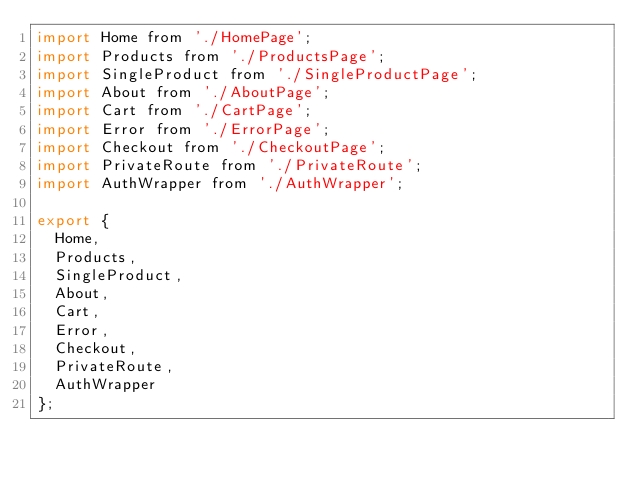Convert code to text. <code><loc_0><loc_0><loc_500><loc_500><_JavaScript_>import Home from './HomePage';
import Products from './ProductsPage';
import SingleProduct from './SingleProductPage';
import About from './AboutPage';
import Cart from './CartPage';
import Error from './ErrorPage';
import Checkout from './CheckoutPage';
import PrivateRoute from './PrivateRoute';
import AuthWrapper from './AuthWrapper';

export {
  Home,
  Products,
  SingleProduct,
  About,
  Cart,
  Error,
  Checkout,
  PrivateRoute,
  AuthWrapper
};
</code> 